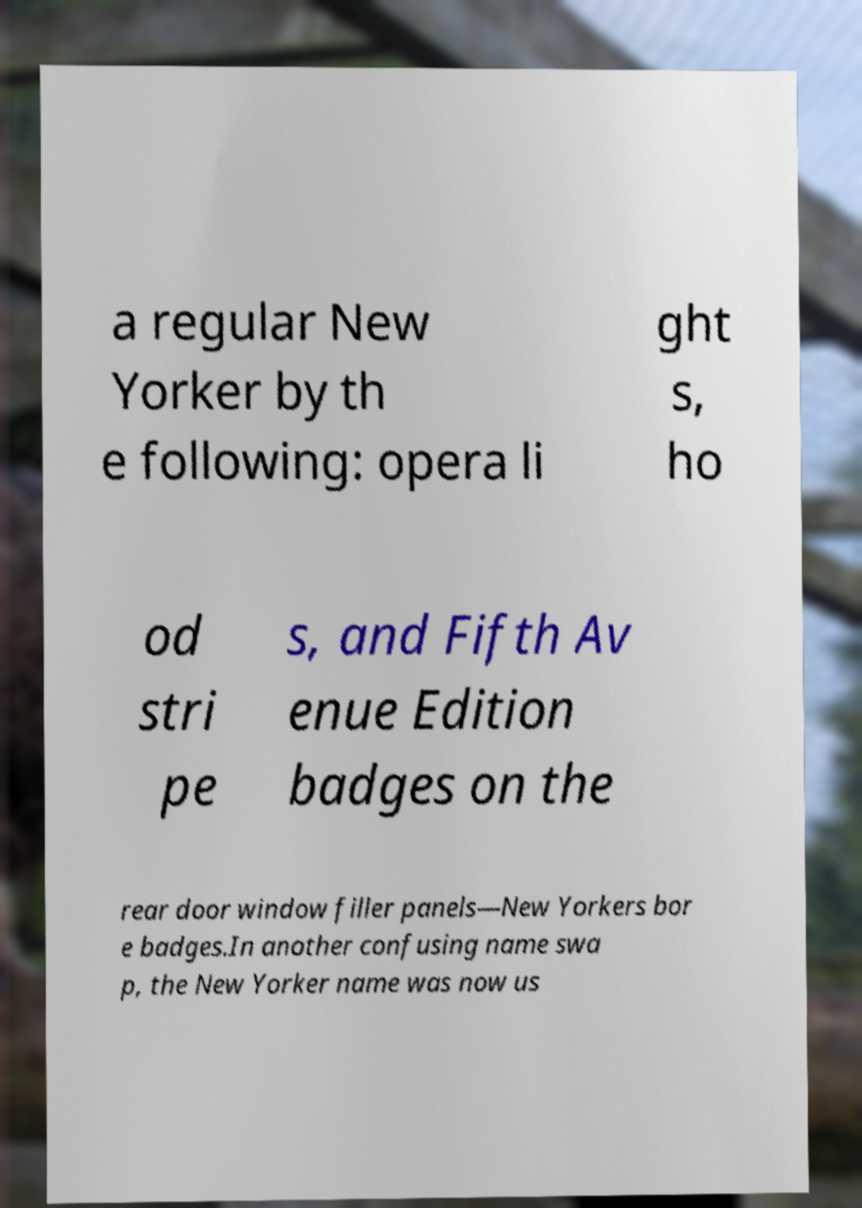Please identify and transcribe the text found in this image. a regular New Yorker by th e following: opera li ght s, ho od stri pe s, and Fifth Av enue Edition badges on the rear door window filler panels—New Yorkers bor e badges.In another confusing name swa p, the New Yorker name was now us 